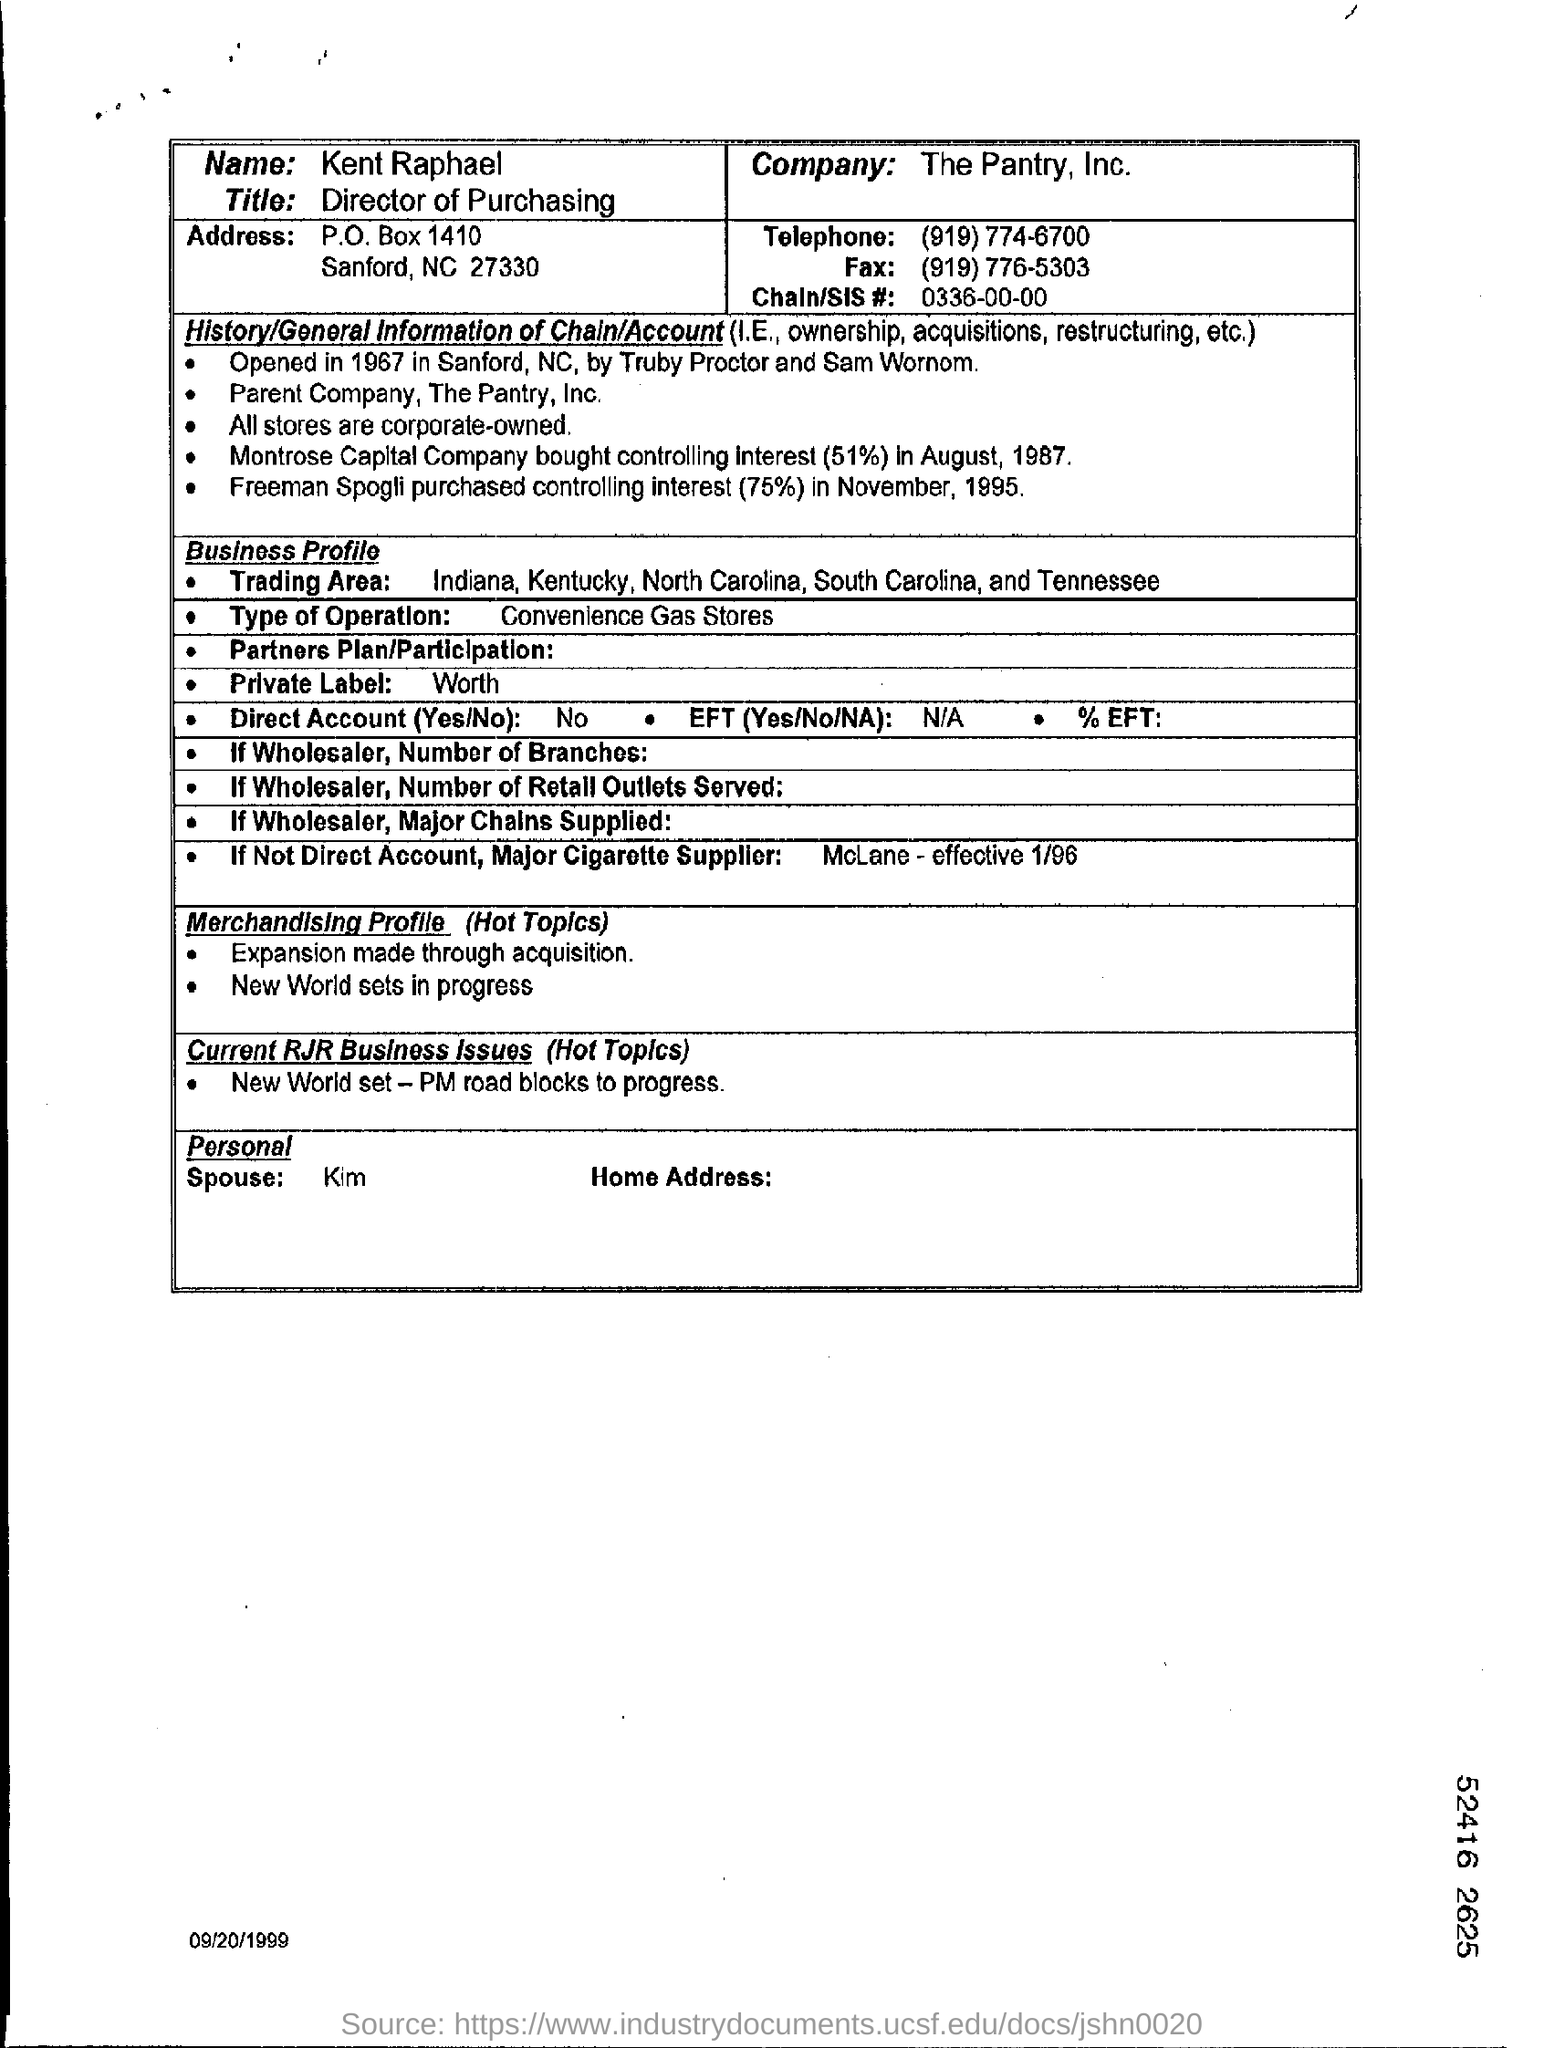Specify some key components in this picture. The Pantry, Inc. is the company. The Chain/SIS number is 0336-00-00. The fax number is (919) 776-5303. The title is "Director of Purchasing. The telephone is a device that is used for communication through the transmission of voice signals over a electrical system. The number "919 774-6700" is associated with this device. 